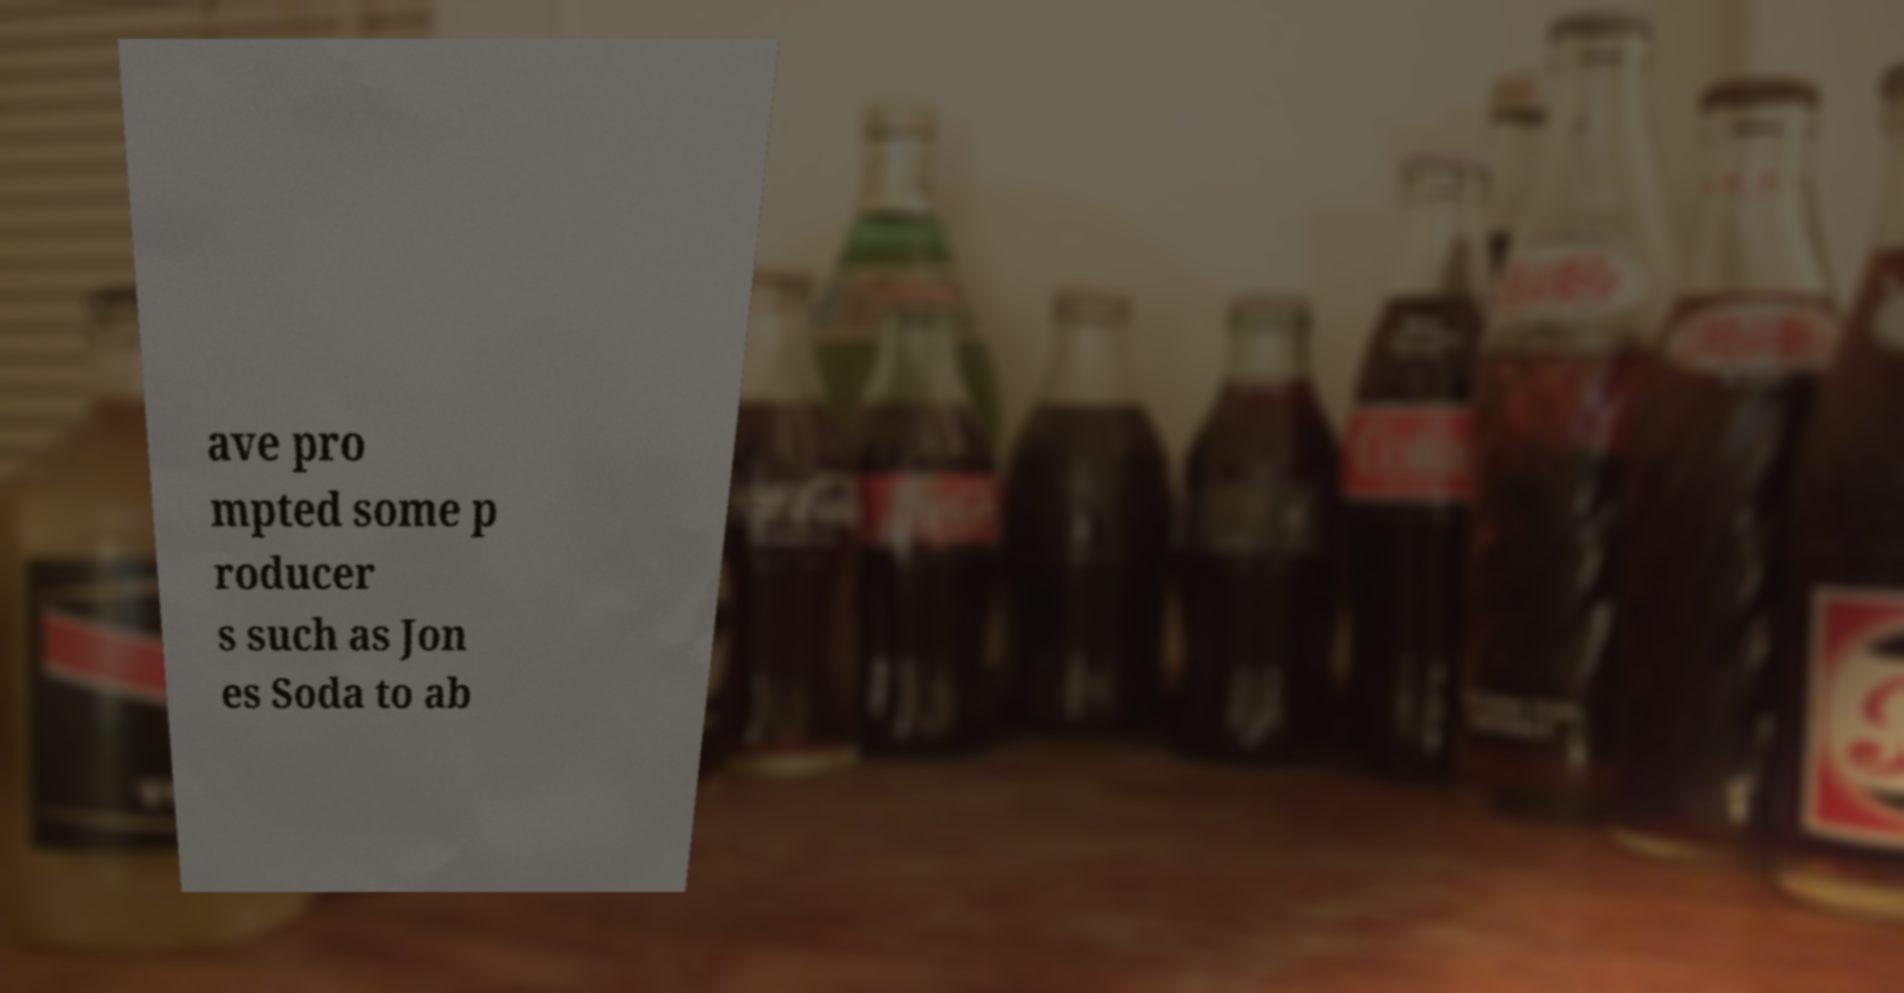There's text embedded in this image that I need extracted. Can you transcribe it verbatim? ave pro mpted some p roducer s such as Jon es Soda to ab 